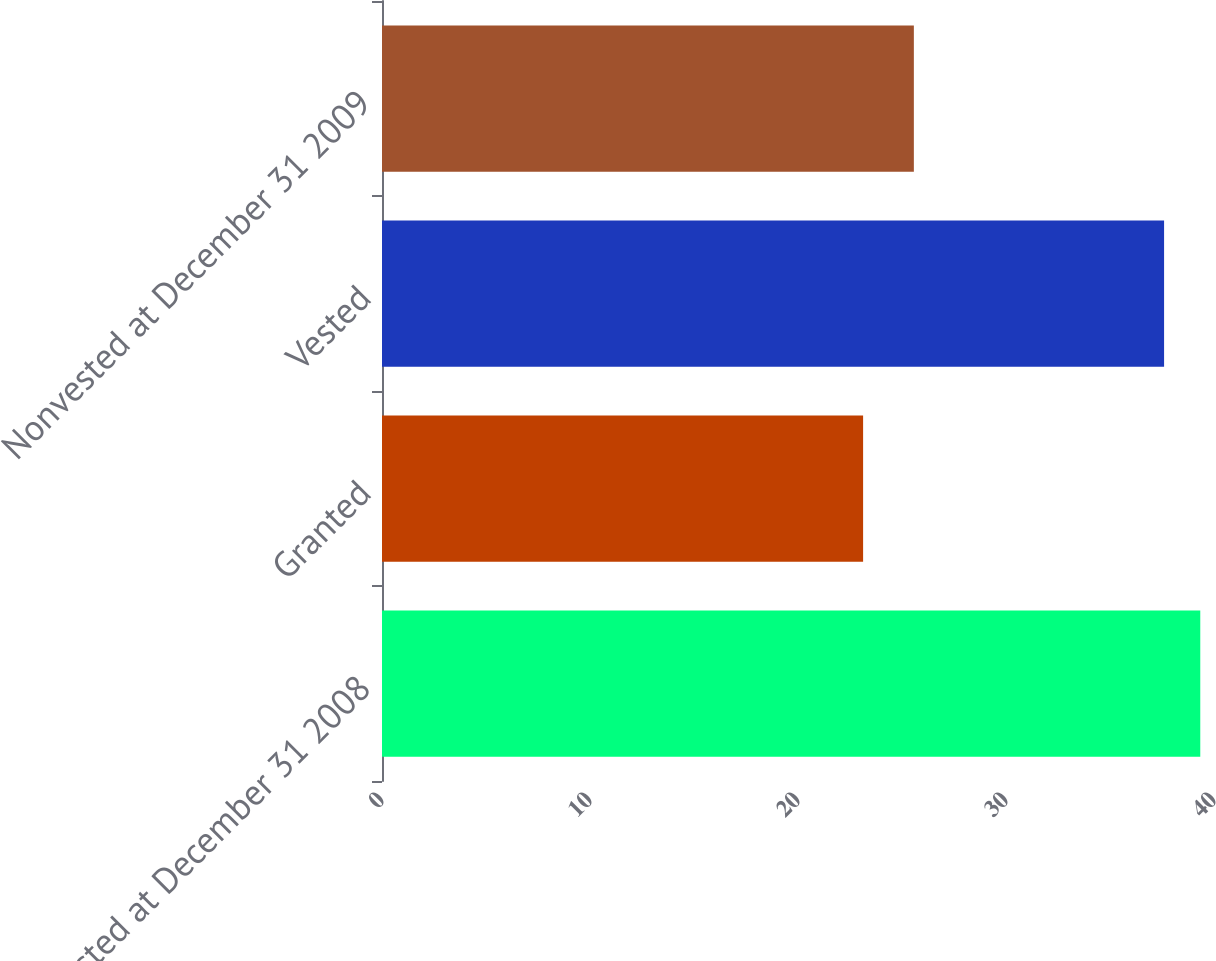Convert chart to OTSL. <chart><loc_0><loc_0><loc_500><loc_500><bar_chart><fcel>Nonvested at December 31 2008<fcel>Granted<fcel>Vested<fcel>Nonvested at December 31 2009<nl><fcel>39.34<fcel>23.13<fcel>37.6<fcel>25.57<nl></chart> 